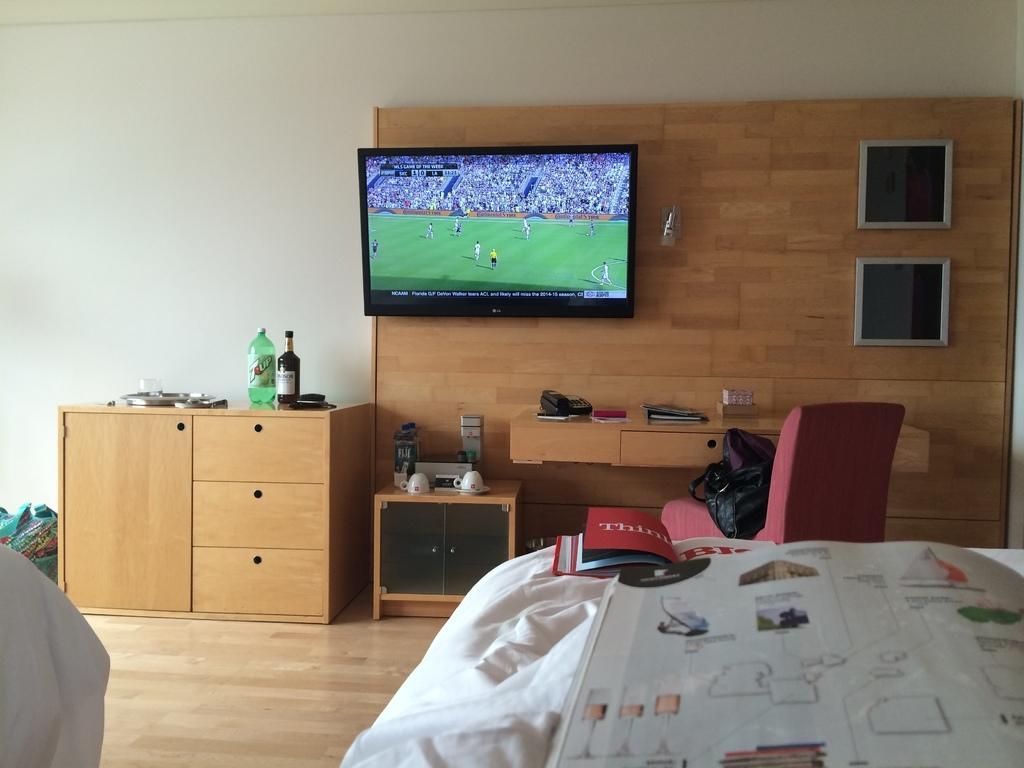How would you summarize this image in a sentence or two? In this image on the bottom of the right corner there is one bed and on the bed there are some books and on the top there is wall and on the right side there is one cupboard and one television is there on the cupboard and on the cupboard there is one telephone books are there. Beside that cupboard there is one table and on the table there are some music systems are there and beside that table there is another cupboard and on that cupboard there are two bottles. 